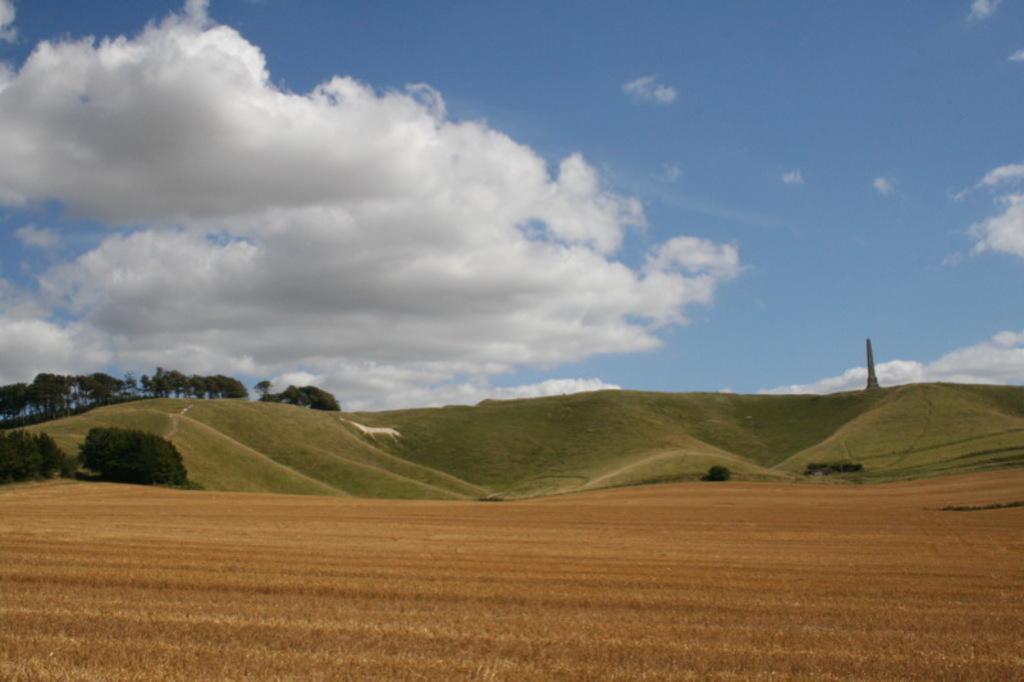Please provide a concise description of this image. In this picture I can see trees and grass on the ground I can see plants and a tower and I can see blue cloudy sky. 